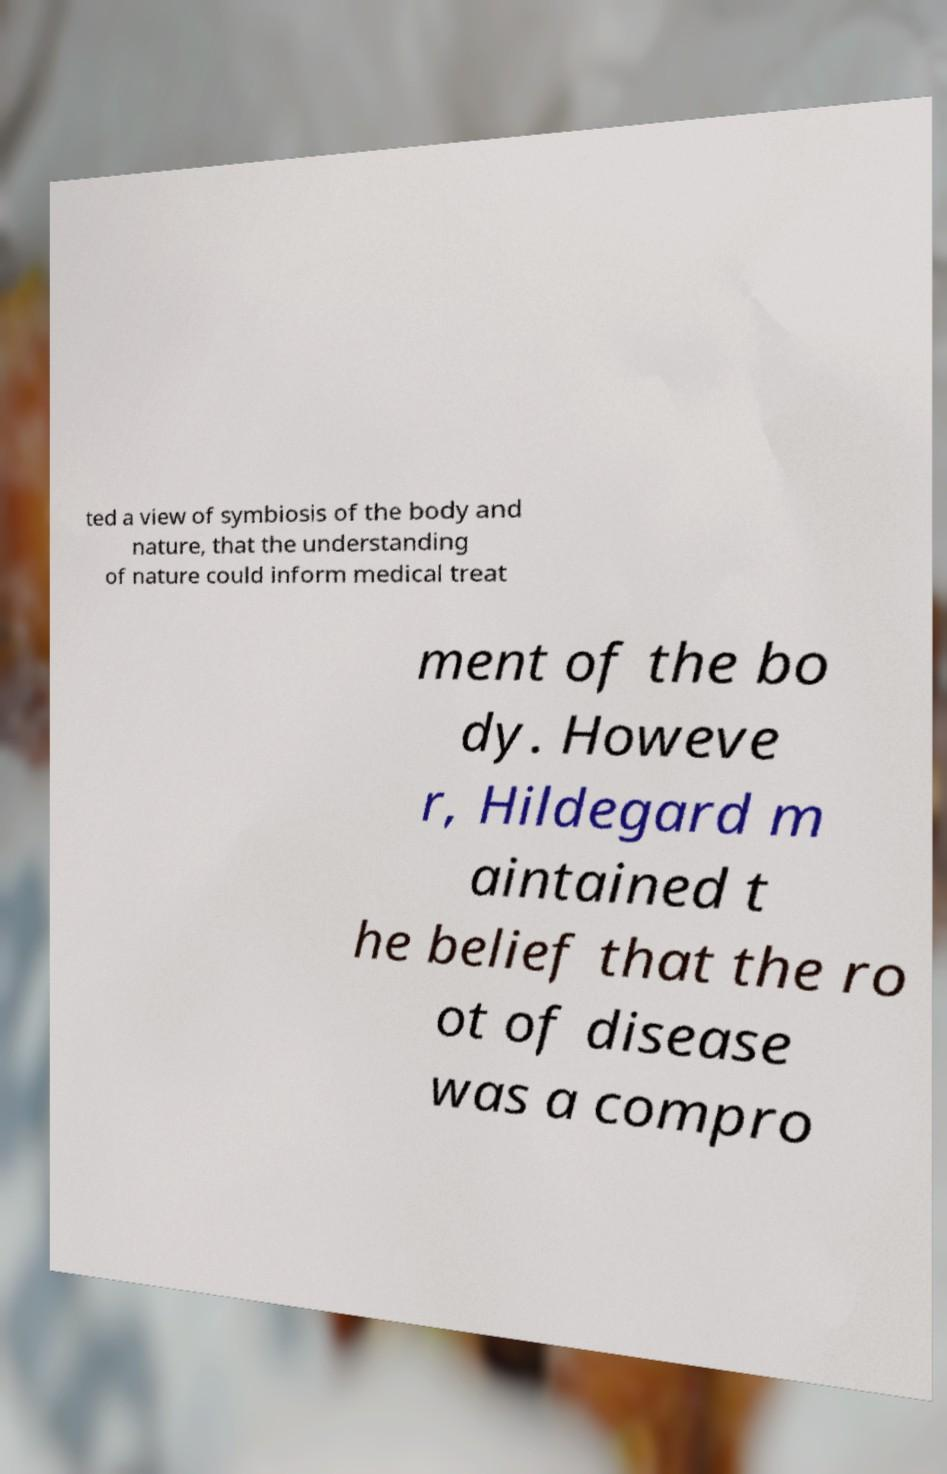Please read and relay the text visible in this image. What does it say? ted a view of symbiosis of the body and nature, that the understanding of nature could inform medical treat ment of the bo dy. Howeve r, Hildegard m aintained t he belief that the ro ot of disease was a compro 